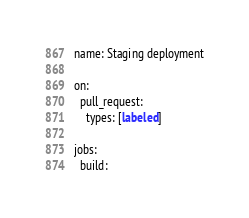<code> <loc_0><loc_0><loc_500><loc_500><_YAML_>name: Staging deployment

on:
  pull_request:
    types: [labeled]

jobs:
  build:</code> 